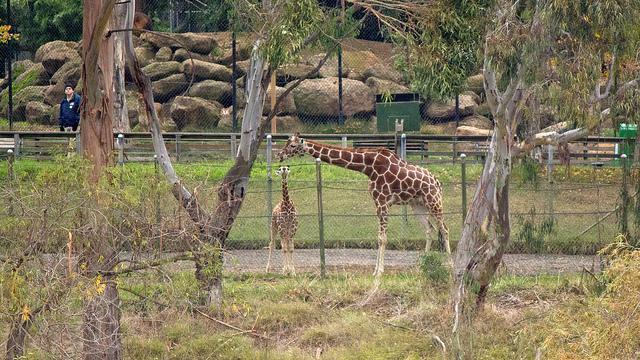How many people are watching the animal?
Give a very brief answer. 1. How many animals are depicted?
Give a very brief answer. 2. How many boats are in the picture?
Give a very brief answer. 0. 